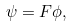Convert formula to latex. <formula><loc_0><loc_0><loc_500><loc_500>\psi = F \phi ,</formula> 